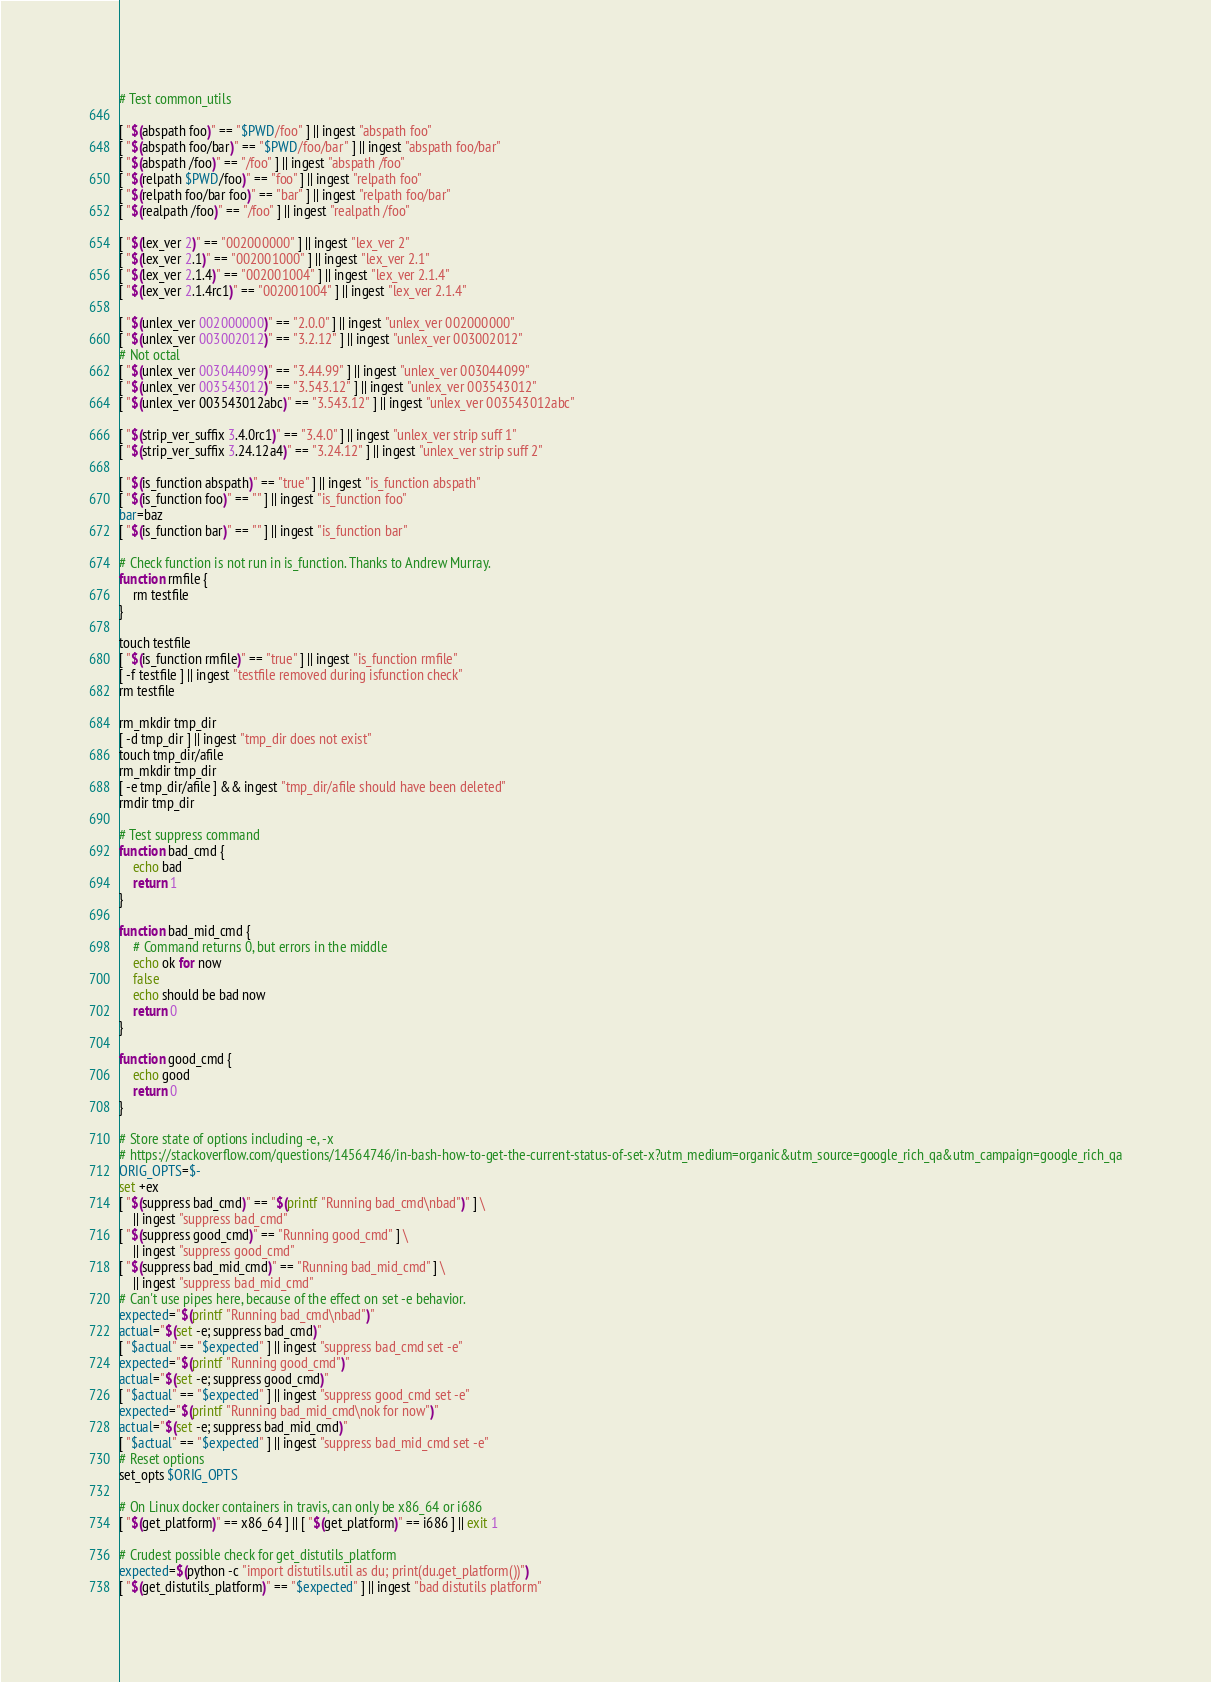Convert code to text. <code><loc_0><loc_0><loc_500><loc_500><_Bash_># Test common_utils

[ "$(abspath foo)" == "$PWD/foo" ] || ingest "abspath foo"
[ "$(abspath foo/bar)" == "$PWD/foo/bar" ] || ingest "abspath foo/bar"
[ "$(abspath /foo)" == "/foo" ] || ingest "abspath /foo"
[ "$(relpath $PWD/foo)" == "foo" ] || ingest "relpath foo"
[ "$(relpath foo/bar foo)" == "bar" ] || ingest "relpath foo/bar"
[ "$(realpath /foo)" == "/foo" ] || ingest "realpath /foo"

[ "$(lex_ver 2)" == "002000000" ] || ingest "lex_ver 2"
[ "$(lex_ver 2.1)" == "002001000" ] || ingest "lex_ver 2.1"
[ "$(lex_ver 2.1.4)" == "002001004" ] || ingest "lex_ver 2.1.4"
[ "$(lex_ver 2.1.4rc1)" == "002001004" ] || ingest "lex_ver 2.1.4"

[ "$(unlex_ver 002000000)" == "2.0.0" ] || ingest "unlex_ver 002000000"
[ "$(unlex_ver 003002012)" == "3.2.12" ] || ingest "unlex_ver 003002012"
# Not octal
[ "$(unlex_ver 003044099)" == "3.44.99" ] || ingest "unlex_ver 003044099"
[ "$(unlex_ver 003543012)" == "3.543.12" ] || ingest "unlex_ver 003543012"
[ "$(unlex_ver 003543012abc)" == "3.543.12" ] || ingest "unlex_ver 003543012abc"

[ "$(strip_ver_suffix 3.4.0rc1)" == "3.4.0" ] || ingest "unlex_ver strip suff 1"
[ "$(strip_ver_suffix 3.24.12a4)" == "3.24.12" ] || ingest "unlex_ver strip suff 2"

[ "$(is_function abspath)" == "true" ] || ingest "is_function abspath"
[ "$(is_function foo)" == "" ] || ingest "is_function foo"
bar=baz
[ "$(is_function bar)" == "" ] || ingest "is_function bar"

# Check function is not run in is_function. Thanks to Andrew Murray.
function rmfile {
    rm testfile
}

touch testfile
[ "$(is_function rmfile)" == "true" ] || ingest "is_function rmfile"
[ -f testfile ] || ingest "testfile removed during isfunction check"
rm testfile

rm_mkdir tmp_dir
[ -d tmp_dir ] || ingest "tmp_dir does not exist"
touch tmp_dir/afile
rm_mkdir tmp_dir
[ -e tmp_dir/afile ] && ingest "tmp_dir/afile should have been deleted"
rmdir tmp_dir

# Test suppress command
function bad_cmd {
    echo bad
    return 1
}

function bad_mid_cmd {
    # Command returns 0, but errors in the middle
    echo ok for now
    false
    echo should be bad now
    return 0
}

function good_cmd {
    echo good
    return 0
}

# Store state of options including -e, -x
# https://stackoverflow.com/questions/14564746/in-bash-how-to-get-the-current-status-of-set-x?utm_medium=organic&utm_source=google_rich_qa&utm_campaign=google_rich_qa
ORIG_OPTS=$-
set +ex
[ "$(suppress bad_cmd)" == "$(printf "Running bad_cmd\nbad")" ] \
    || ingest "suppress bad_cmd"
[ "$(suppress good_cmd)" == "Running good_cmd" ] \
    || ingest "suppress good_cmd"
[ "$(suppress bad_mid_cmd)" == "Running bad_mid_cmd" ] \
    || ingest "suppress bad_mid_cmd"
# Can't use pipes here, because of the effect on set -e behavior.
expected="$(printf "Running bad_cmd\nbad")"
actual="$(set -e; suppress bad_cmd)"
[ "$actual" == "$expected" ] || ingest "suppress bad_cmd set -e"
expected="$(printf "Running good_cmd")"
actual="$(set -e; suppress good_cmd)"
[ "$actual" == "$expected" ] || ingest "suppress good_cmd set -e"
expected="$(printf "Running bad_mid_cmd\nok for now")"
actual="$(set -e; suppress bad_mid_cmd)"
[ "$actual" == "$expected" ] || ingest "suppress bad_mid_cmd set -e"
# Reset options
set_opts $ORIG_OPTS

# On Linux docker containers in travis, can only be x86_64 or i686
[ "$(get_platform)" == x86_64 ] || [ "$(get_platform)" == i686 ] || exit 1

# Crudest possible check for get_distutils_platform
expected=$(python -c "import distutils.util as du; print(du.get_platform())")
[ "$(get_distutils_platform)" == "$expected" ] || ingest "bad distutils platform"
</code> 